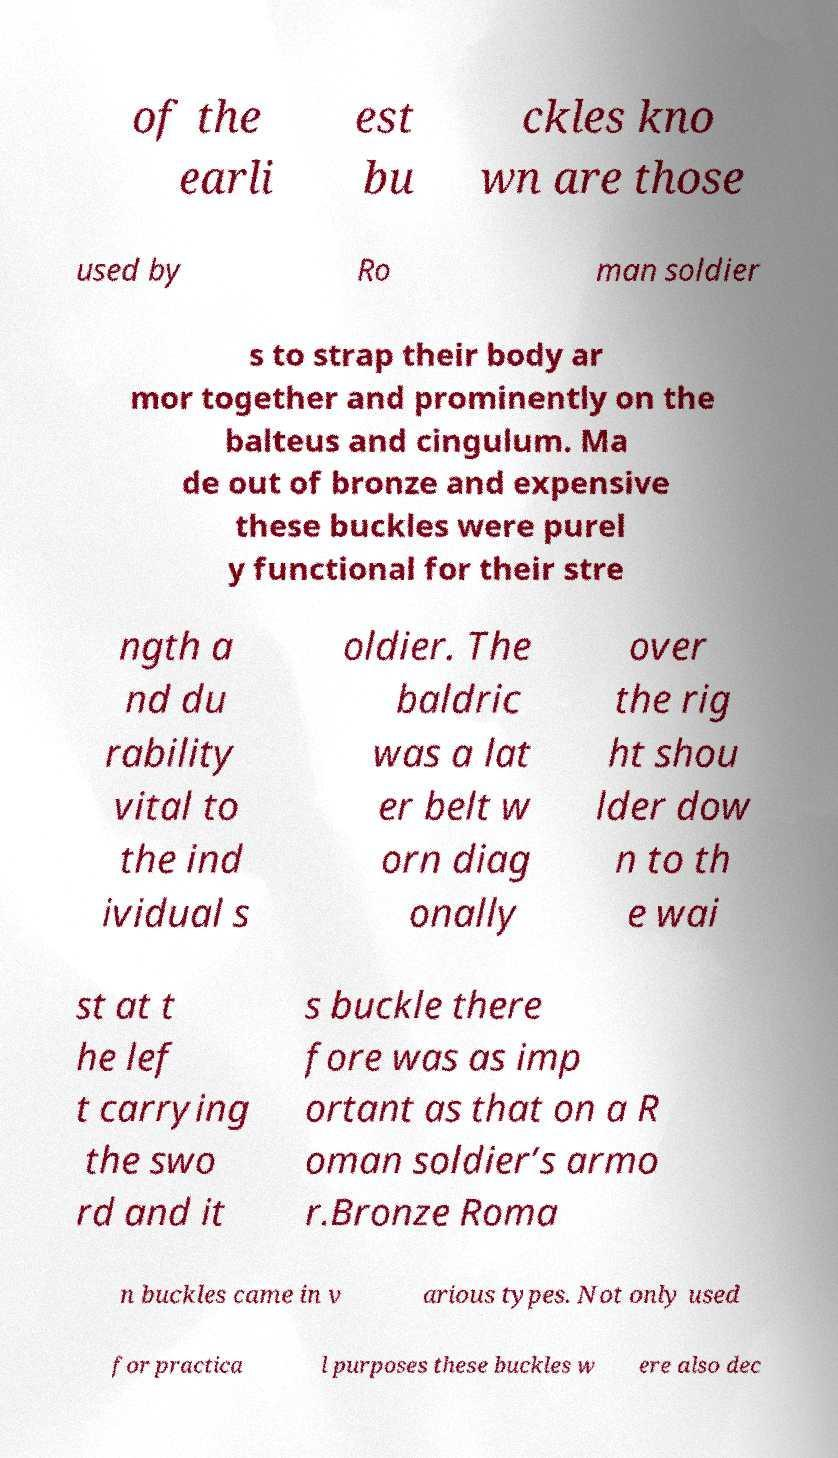Please identify and transcribe the text found in this image. of the earli est bu ckles kno wn are those used by Ro man soldier s to strap their body ar mor together and prominently on the balteus and cingulum. Ma de out of bronze and expensive these buckles were purel y functional for their stre ngth a nd du rability vital to the ind ividual s oldier. The baldric was a lat er belt w orn diag onally over the rig ht shou lder dow n to th e wai st at t he lef t carrying the swo rd and it s buckle there fore was as imp ortant as that on a R oman soldier’s armo r.Bronze Roma n buckles came in v arious types. Not only used for practica l purposes these buckles w ere also dec 